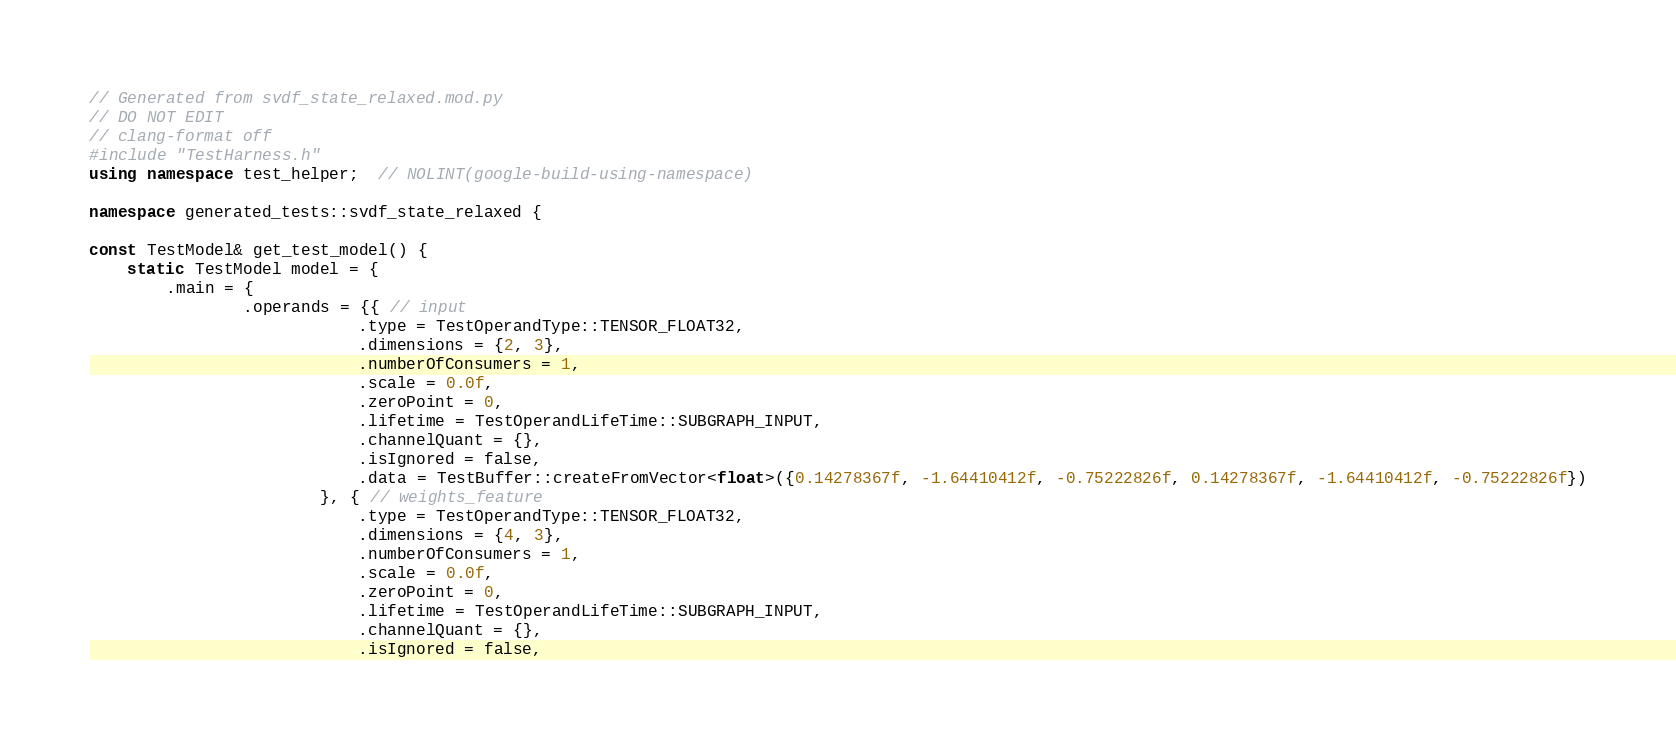Convert code to text. <code><loc_0><loc_0><loc_500><loc_500><_C++_>// Generated from svdf_state_relaxed.mod.py
// DO NOT EDIT
// clang-format off
#include "TestHarness.h"
using namespace test_helper;  // NOLINT(google-build-using-namespace)

namespace generated_tests::svdf_state_relaxed {

const TestModel& get_test_model() {
    static TestModel model = {
        .main = {
                .operands = {{ // input
                            .type = TestOperandType::TENSOR_FLOAT32,
                            .dimensions = {2, 3},
                            .numberOfConsumers = 1,
                            .scale = 0.0f,
                            .zeroPoint = 0,
                            .lifetime = TestOperandLifeTime::SUBGRAPH_INPUT,
                            .channelQuant = {},
                            .isIgnored = false,
                            .data = TestBuffer::createFromVector<float>({0.14278367f, -1.64410412f, -0.75222826f, 0.14278367f, -1.64410412f, -0.75222826f})
                        }, { // weights_feature
                            .type = TestOperandType::TENSOR_FLOAT32,
                            .dimensions = {4, 3},
                            .numberOfConsumers = 1,
                            .scale = 0.0f,
                            .zeroPoint = 0,
                            .lifetime = TestOperandLifeTime::SUBGRAPH_INPUT,
                            .channelQuant = {},
                            .isIgnored = false,</code> 